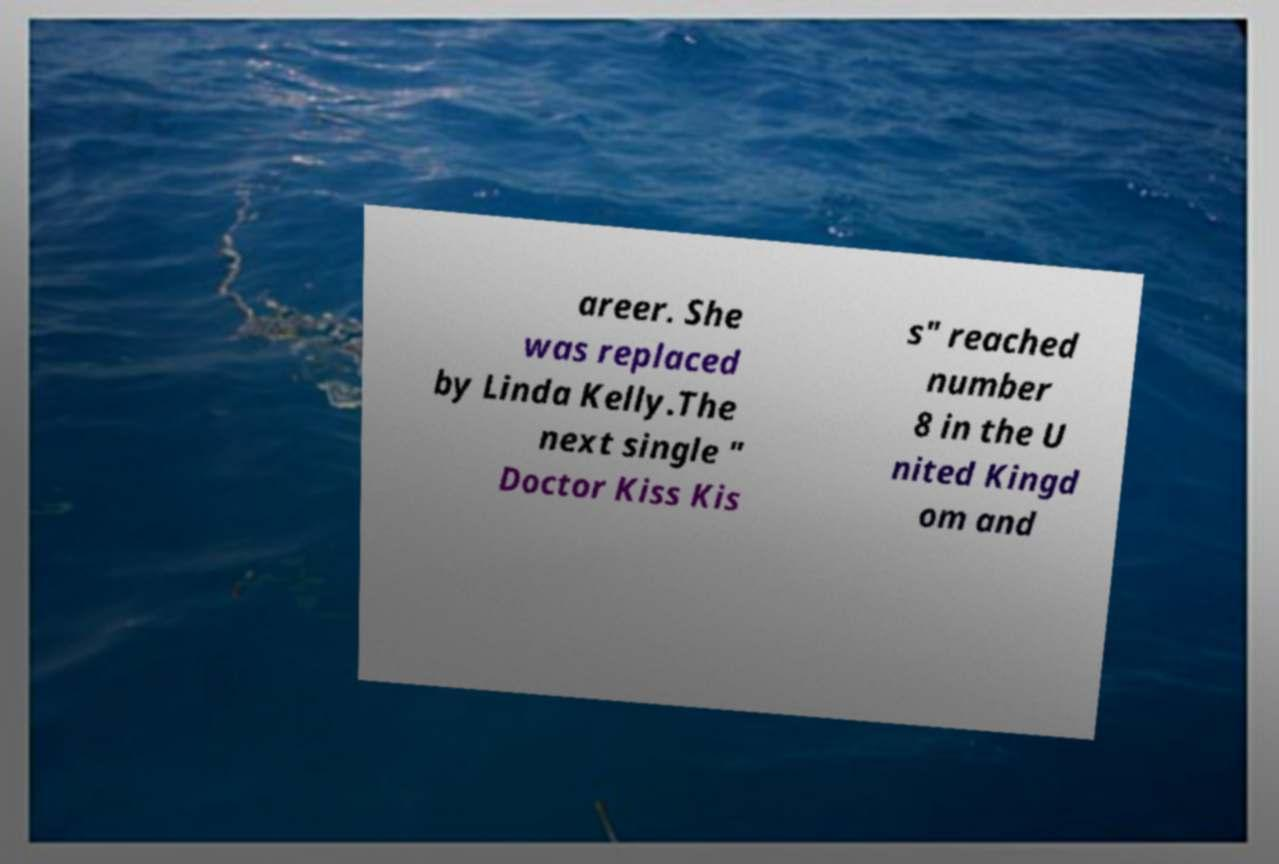What messages or text are displayed in this image? I need them in a readable, typed format. areer. She was replaced by Linda Kelly.The next single " Doctor Kiss Kis s" reached number 8 in the U nited Kingd om and 